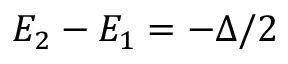Convert formula to latex. <formula><loc_0><loc_0><loc_500><loc_500>E _ { 2 } - E _ { 1 } = - \Delta / 2</formula> 